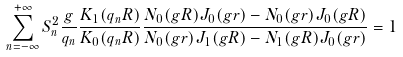Convert formula to latex. <formula><loc_0><loc_0><loc_500><loc_500>\sum _ { n = - \infty } ^ { + \infty } S _ { n } ^ { 2 } \frac { g } { q _ { n } } \frac { K _ { 1 } ( q _ { n } R ) } { K _ { 0 } ( q _ { n } R ) } \frac { N _ { 0 } ( g R ) J _ { 0 } ( g r ) - N _ { 0 } ( g r ) J _ { 0 } ( g R ) } { N _ { 0 } ( g r ) J _ { 1 } ( g R ) - N _ { 1 } ( g R ) J _ { 0 } ( g r ) } = 1</formula> 